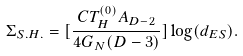<formula> <loc_0><loc_0><loc_500><loc_500>\Sigma _ { S . H . } = [ \frac { C T _ { H } ^ { ( 0 ) } A _ { D - 2 } } { 4 G _ { N } ( D - 3 ) } ] \log ( d _ { E S } ) .</formula> 